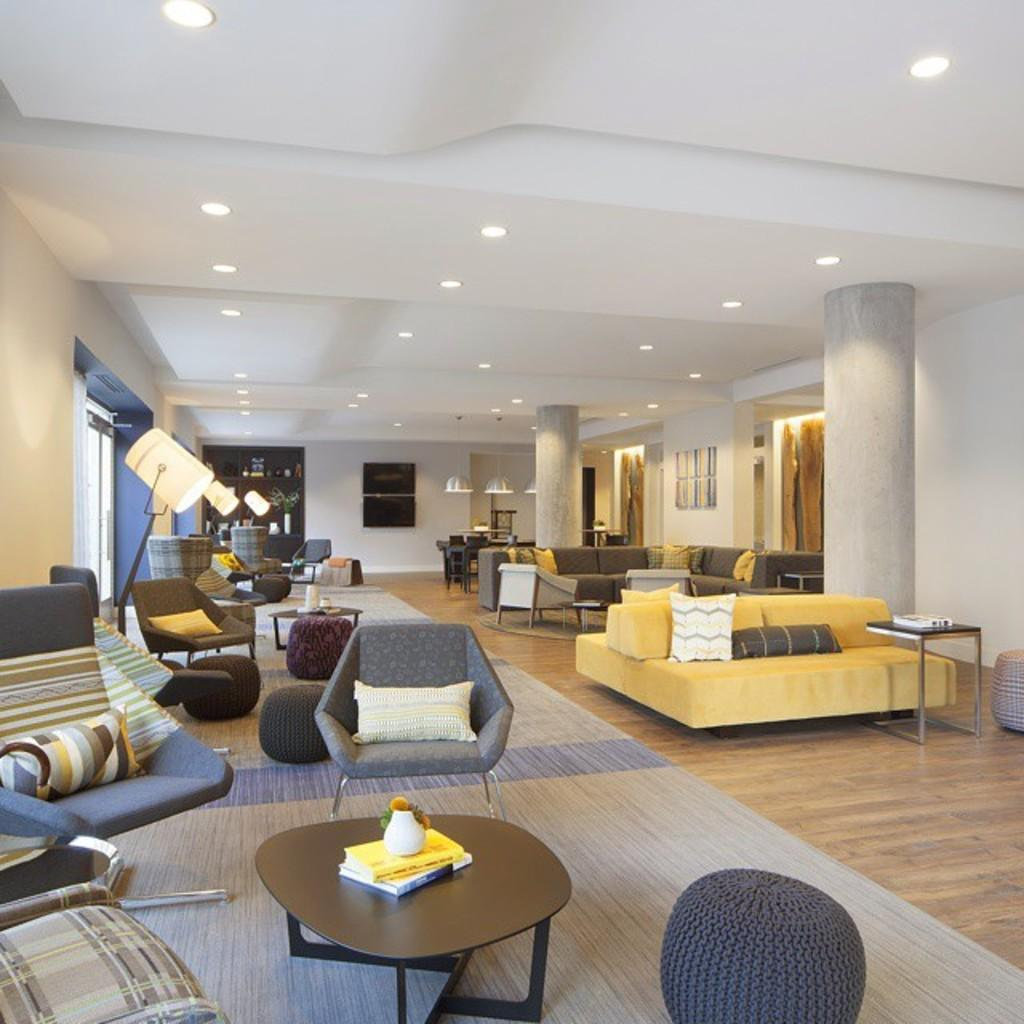What type of space is shown in the image? The image depicts the interior of a hall. What furniture is present in the hall? There are chairs and tables in the hall. What can be used for illumination in the hall? There are lights in the hall. What can be used for comfort in the hall? There are pillows in the hall. What type of pear is being polished on one of the tables in the image? There is no pear or polishing activity present in the image. 